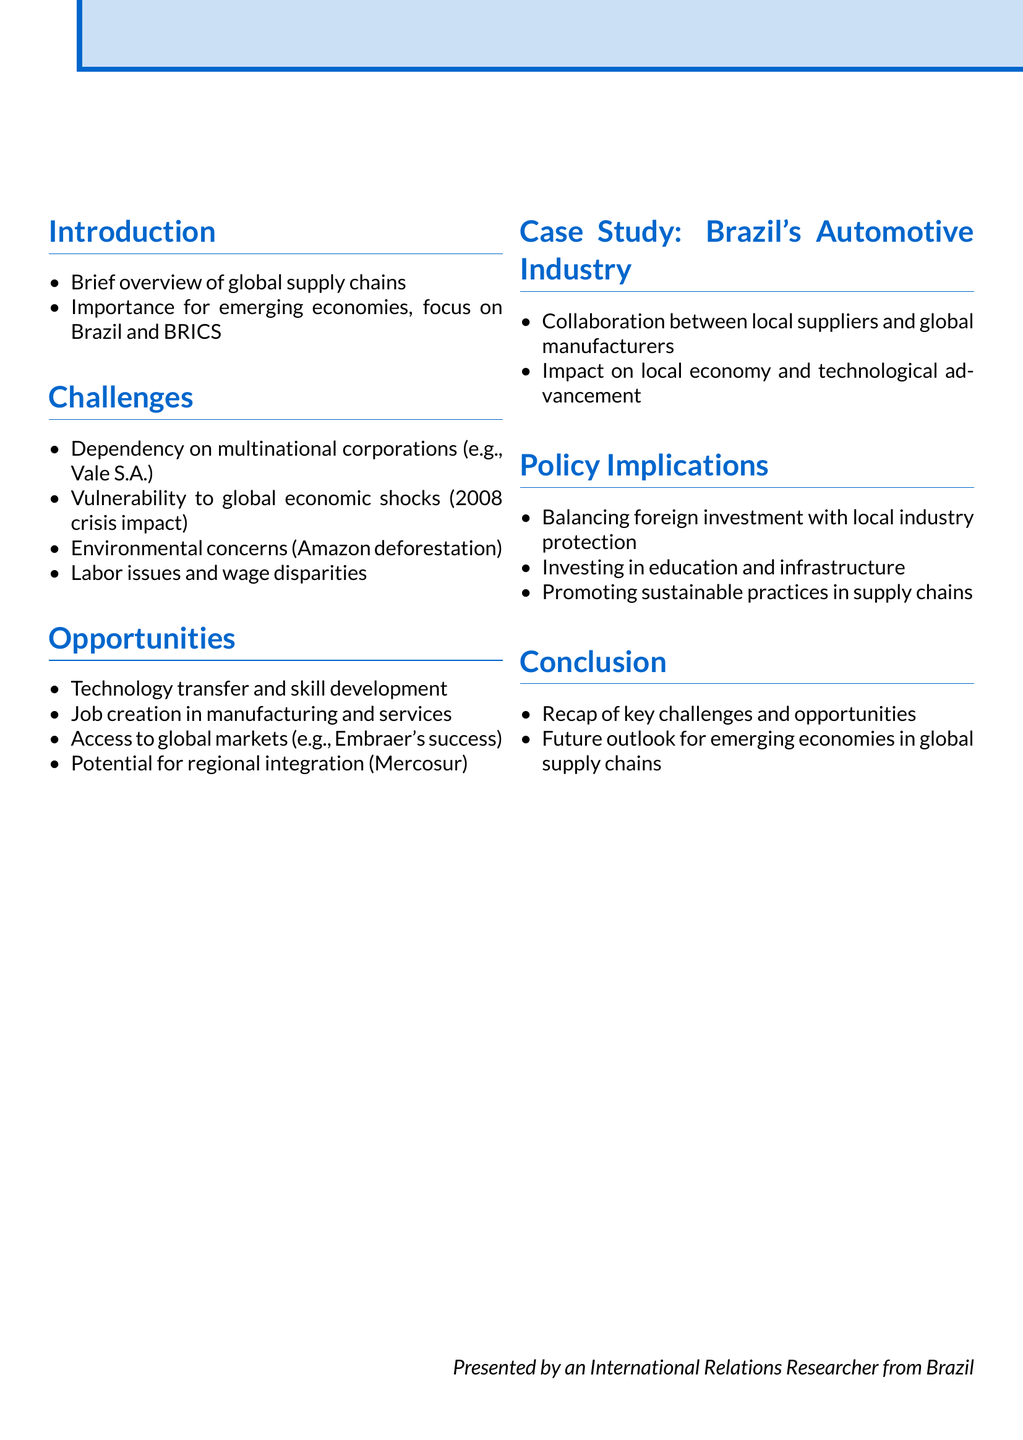What is the focus country in the document? The document emphasizes the importance of global supply chains for Brazil and other BRICS nations.
Answer: Brazil Which industry is used as a case study in the document? The case study in the document highlights Brazil's automotive industry.
Answer: Automotive What major event's impact on Brazil is mentioned? The document discusses the vulnerability of emerging economies to global economic shocks, specifically referencing the 2008 financial crisis impact on Brazil.
Answer: 2008 financial crisis Name one opportunity presented in the document. The document lists various opportunities for emerging economies, one of which is technology transfer and skill development.
Answer: Technology transfer What trade bloc is mentioned in the context of regional integration? The document refers to Mercosur as a potential for regional integration for emerging economies.
Answer: Mercosur What is one environmental concern related to global supply chains? The document highlights Amazon deforestation as a significant environmental concern due to agricultural expansion related to global supply chains.
Answer: Amazon deforestation What is a key policy implication mentioned in the document? The document underscores the importance of balancing foreign investment with local industry protection as a policy implication.
Answer: Balancing foreign investment What does the document suggest investing in for future growth? The document suggests investing in education and infrastructure as crucial for the future growth of emerging economies in global supply chains.
Answer: Education and infrastructure What is one example of a multinational corporation in Brazil mentioned? Vale S.A. is cited as an example of a multinational corporation relevant to the mining sector in Brazil.
Answer: Vale S.A 